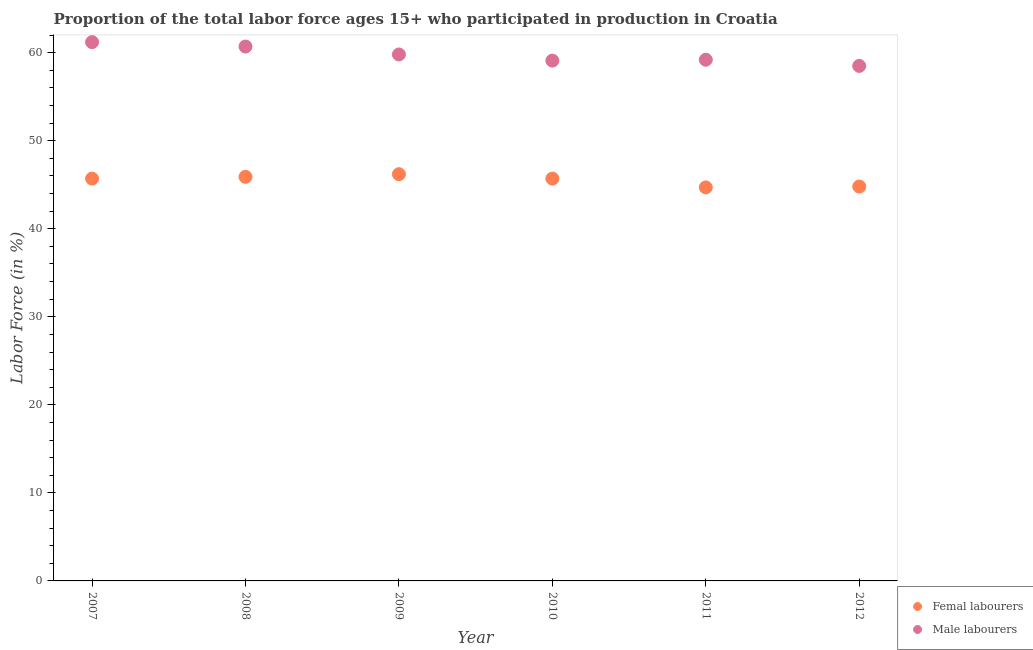How many different coloured dotlines are there?
Your answer should be very brief. 2. What is the percentage of female labor force in 2008?
Ensure brevity in your answer.  45.9. Across all years, what is the maximum percentage of male labour force?
Give a very brief answer. 61.2. Across all years, what is the minimum percentage of male labour force?
Offer a very short reply. 58.5. In which year was the percentage of male labour force maximum?
Provide a succinct answer. 2007. In which year was the percentage of male labour force minimum?
Keep it short and to the point. 2012. What is the total percentage of male labour force in the graph?
Your response must be concise. 358.5. What is the difference between the percentage of male labour force in 2010 and the percentage of female labor force in 2009?
Your answer should be compact. 12.9. What is the average percentage of female labor force per year?
Your answer should be very brief. 45.5. In the year 2009, what is the difference between the percentage of female labor force and percentage of male labour force?
Give a very brief answer. -13.6. What is the ratio of the percentage of female labor force in 2008 to that in 2010?
Provide a short and direct response. 1. What is the difference between the highest and the second highest percentage of female labor force?
Ensure brevity in your answer.  0.3. What is the difference between the highest and the lowest percentage of male labour force?
Ensure brevity in your answer.  2.7. Is the sum of the percentage of male labour force in 2008 and 2011 greater than the maximum percentage of female labor force across all years?
Keep it short and to the point. Yes. Does the percentage of male labour force monotonically increase over the years?
Your response must be concise. No. How many dotlines are there?
Offer a terse response. 2. How many years are there in the graph?
Offer a terse response. 6. Does the graph contain grids?
Keep it short and to the point. No. How many legend labels are there?
Offer a very short reply. 2. What is the title of the graph?
Give a very brief answer. Proportion of the total labor force ages 15+ who participated in production in Croatia. What is the label or title of the X-axis?
Your answer should be compact. Year. What is the label or title of the Y-axis?
Provide a succinct answer. Labor Force (in %). What is the Labor Force (in %) of Femal labourers in 2007?
Your answer should be very brief. 45.7. What is the Labor Force (in %) of Male labourers in 2007?
Your answer should be compact. 61.2. What is the Labor Force (in %) in Femal labourers in 2008?
Provide a short and direct response. 45.9. What is the Labor Force (in %) in Male labourers in 2008?
Give a very brief answer. 60.7. What is the Labor Force (in %) of Femal labourers in 2009?
Make the answer very short. 46.2. What is the Labor Force (in %) in Male labourers in 2009?
Offer a terse response. 59.8. What is the Labor Force (in %) in Femal labourers in 2010?
Ensure brevity in your answer.  45.7. What is the Labor Force (in %) in Male labourers in 2010?
Provide a succinct answer. 59.1. What is the Labor Force (in %) in Femal labourers in 2011?
Give a very brief answer. 44.7. What is the Labor Force (in %) in Male labourers in 2011?
Keep it short and to the point. 59.2. What is the Labor Force (in %) of Femal labourers in 2012?
Your answer should be very brief. 44.8. What is the Labor Force (in %) in Male labourers in 2012?
Your answer should be compact. 58.5. Across all years, what is the maximum Labor Force (in %) in Femal labourers?
Give a very brief answer. 46.2. Across all years, what is the maximum Labor Force (in %) in Male labourers?
Your answer should be compact. 61.2. Across all years, what is the minimum Labor Force (in %) of Femal labourers?
Your response must be concise. 44.7. Across all years, what is the minimum Labor Force (in %) in Male labourers?
Your answer should be compact. 58.5. What is the total Labor Force (in %) of Femal labourers in the graph?
Your answer should be compact. 273. What is the total Labor Force (in %) of Male labourers in the graph?
Make the answer very short. 358.5. What is the difference between the Labor Force (in %) in Male labourers in 2007 and that in 2008?
Make the answer very short. 0.5. What is the difference between the Labor Force (in %) in Femal labourers in 2007 and that in 2009?
Offer a very short reply. -0.5. What is the difference between the Labor Force (in %) in Male labourers in 2007 and that in 2009?
Provide a succinct answer. 1.4. What is the difference between the Labor Force (in %) of Femal labourers in 2007 and that in 2010?
Offer a terse response. 0. What is the difference between the Labor Force (in %) of Femal labourers in 2007 and that in 2011?
Keep it short and to the point. 1. What is the difference between the Labor Force (in %) in Femal labourers in 2007 and that in 2012?
Provide a short and direct response. 0.9. What is the difference between the Labor Force (in %) of Male labourers in 2007 and that in 2012?
Provide a succinct answer. 2.7. What is the difference between the Labor Force (in %) of Femal labourers in 2008 and that in 2010?
Offer a terse response. 0.2. What is the difference between the Labor Force (in %) in Femal labourers in 2008 and that in 2011?
Offer a very short reply. 1.2. What is the difference between the Labor Force (in %) of Male labourers in 2008 and that in 2011?
Make the answer very short. 1.5. What is the difference between the Labor Force (in %) in Femal labourers in 2008 and that in 2012?
Offer a terse response. 1.1. What is the difference between the Labor Force (in %) of Male labourers in 2008 and that in 2012?
Provide a succinct answer. 2.2. What is the difference between the Labor Force (in %) of Male labourers in 2009 and that in 2010?
Offer a terse response. 0.7. What is the difference between the Labor Force (in %) of Femal labourers in 2009 and that in 2012?
Your answer should be very brief. 1.4. What is the difference between the Labor Force (in %) in Male labourers in 2009 and that in 2012?
Your answer should be very brief. 1.3. What is the difference between the Labor Force (in %) in Male labourers in 2010 and that in 2012?
Your answer should be compact. 0.6. What is the difference between the Labor Force (in %) in Femal labourers in 2011 and that in 2012?
Give a very brief answer. -0.1. What is the difference between the Labor Force (in %) in Femal labourers in 2007 and the Labor Force (in %) in Male labourers in 2008?
Give a very brief answer. -15. What is the difference between the Labor Force (in %) of Femal labourers in 2007 and the Labor Force (in %) of Male labourers in 2009?
Your response must be concise. -14.1. What is the difference between the Labor Force (in %) of Femal labourers in 2007 and the Labor Force (in %) of Male labourers in 2011?
Your answer should be compact. -13.5. What is the difference between the Labor Force (in %) of Femal labourers in 2007 and the Labor Force (in %) of Male labourers in 2012?
Keep it short and to the point. -12.8. What is the difference between the Labor Force (in %) in Femal labourers in 2008 and the Labor Force (in %) in Male labourers in 2010?
Give a very brief answer. -13.2. What is the difference between the Labor Force (in %) of Femal labourers in 2009 and the Labor Force (in %) of Male labourers in 2010?
Provide a short and direct response. -12.9. What is the difference between the Labor Force (in %) in Femal labourers in 2011 and the Labor Force (in %) in Male labourers in 2012?
Keep it short and to the point. -13.8. What is the average Labor Force (in %) in Femal labourers per year?
Ensure brevity in your answer.  45.5. What is the average Labor Force (in %) of Male labourers per year?
Offer a very short reply. 59.75. In the year 2007, what is the difference between the Labor Force (in %) in Femal labourers and Labor Force (in %) in Male labourers?
Keep it short and to the point. -15.5. In the year 2008, what is the difference between the Labor Force (in %) of Femal labourers and Labor Force (in %) of Male labourers?
Provide a short and direct response. -14.8. In the year 2012, what is the difference between the Labor Force (in %) of Femal labourers and Labor Force (in %) of Male labourers?
Provide a succinct answer. -13.7. What is the ratio of the Labor Force (in %) of Femal labourers in 2007 to that in 2008?
Give a very brief answer. 1. What is the ratio of the Labor Force (in %) in Male labourers in 2007 to that in 2008?
Offer a terse response. 1.01. What is the ratio of the Labor Force (in %) of Male labourers in 2007 to that in 2009?
Offer a terse response. 1.02. What is the ratio of the Labor Force (in %) in Femal labourers in 2007 to that in 2010?
Provide a short and direct response. 1. What is the ratio of the Labor Force (in %) of Male labourers in 2007 to that in 2010?
Your response must be concise. 1.04. What is the ratio of the Labor Force (in %) of Femal labourers in 2007 to that in 2011?
Your answer should be compact. 1.02. What is the ratio of the Labor Force (in %) in Male labourers in 2007 to that in 2011?
Your answer should be compact. 1.03. What is the ratio of the Labor Force (in %) in Femal labourers in 2007 to that in 2012?
Provide a short and direct response. 1.02. What is the ratio of the Labor Force (in %) in Male labourers in 2007 to that in 2012?
Offer a very short reply. 1.05. What is the ratio of the Labor Force (in %) of Male labourers in 2008 to that in 2009?
Provide a short and direct response. 1.02. What is the ratio of the Labor Force (in %) of Femal labourers in 2008 to that in 2010?
Provide a short and direct response. 1. What is the ratio of the Labor Force (in %) of Male labourers in 2008 to that in 2010?
Ensure brevity in your answer.  1.03. What is the ratio of the Labor Force (in %) of Femal labourers in 2008 to that in 2011?
Your response must be concise. 1.03. What is the ratio of the Labor Force (in %) of Male labourers in 2008 to that in 2011?
Ensure brevity in your answer.  1.03. What is the ratio of the Labor Force (in %) in Femal labourers in 2008 to that in 2012?
Ensure brevity in your answer.  1.02. What is the ratio of the Labor Force (in %) of Male labourers in 2008 to that in 2012?
Your answer should be compact. 1.04. What is the ratio of the Labor Force (in %) in Femal labourers in 2009 to that in 2010?
Your answer should be compact. 1.01. What is the ratio of the Labor Force (in %) in Male labourers in 2009 to that in 2010?
Your response must be concise. 1.01. What is the ratio of the Labor Force (in %) of Femal labourers in 2009 to that in 2011?
Offer a very short reply. 1.03. What is the ratio of the Labor Force (in %) of Male labourers in 2009 to that in 2011?
Your answer should be very brief. 1.01. What is the ratio of the Labor Force (in %) in Femal labourers in 2009 to that in 2012?
Give a very brief answer. 1.03. What is the ratio of the Labor Force (in %) in Male labourers in 2009 to that in 2012?
Provide a short and direct response. 1.02. What is the ratio of the Labor Force (in %) of Femal labourers in 2010 to that in 2011?
Your answer should be compact. 1.02. What is the ratio of the Labor Force (in %) of Male labourers in 2010 to that in 2011?
Your answer should be compact. 1. What is the ratio of the Labor Force (in %) in Femal labourers in 2010 to that in 2012?
Your answer should be compact. 1.02. What is the ratio of the Labor Force (in %) in Male labourers in 2010 to that in 2012?
Your answer should be compact. 1.01. What is the ratio of the Labor Force (in %) in Male labourers in 2011 to that in 2012?
Ensure brevity in your answer.  1.01. What is the difference between the highest and the lowest Labor Force (in %) of Femal labourers?
Provide a short and direct response. 1.5. 